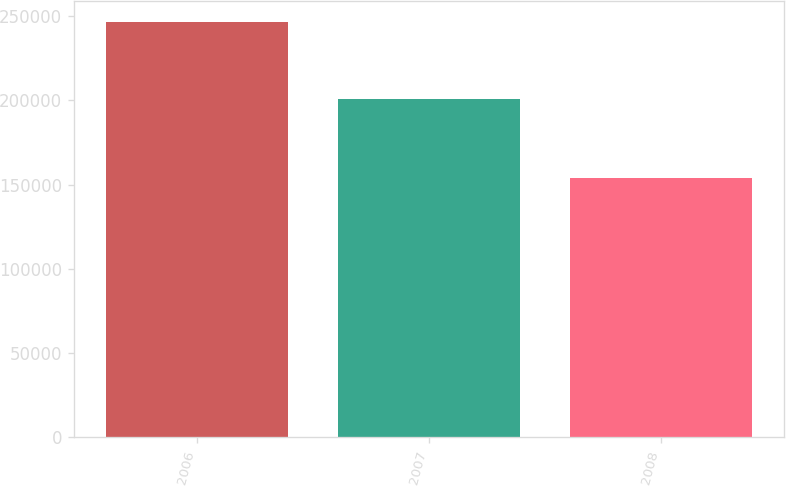<chart> <loc_0><loc_0><loc_500><loc_500><bar_chart><fcel>2006<fcel>2007<fcel>2008<nl><fcel>246588<fcel>200589<fcel>153996<nl></chart> 